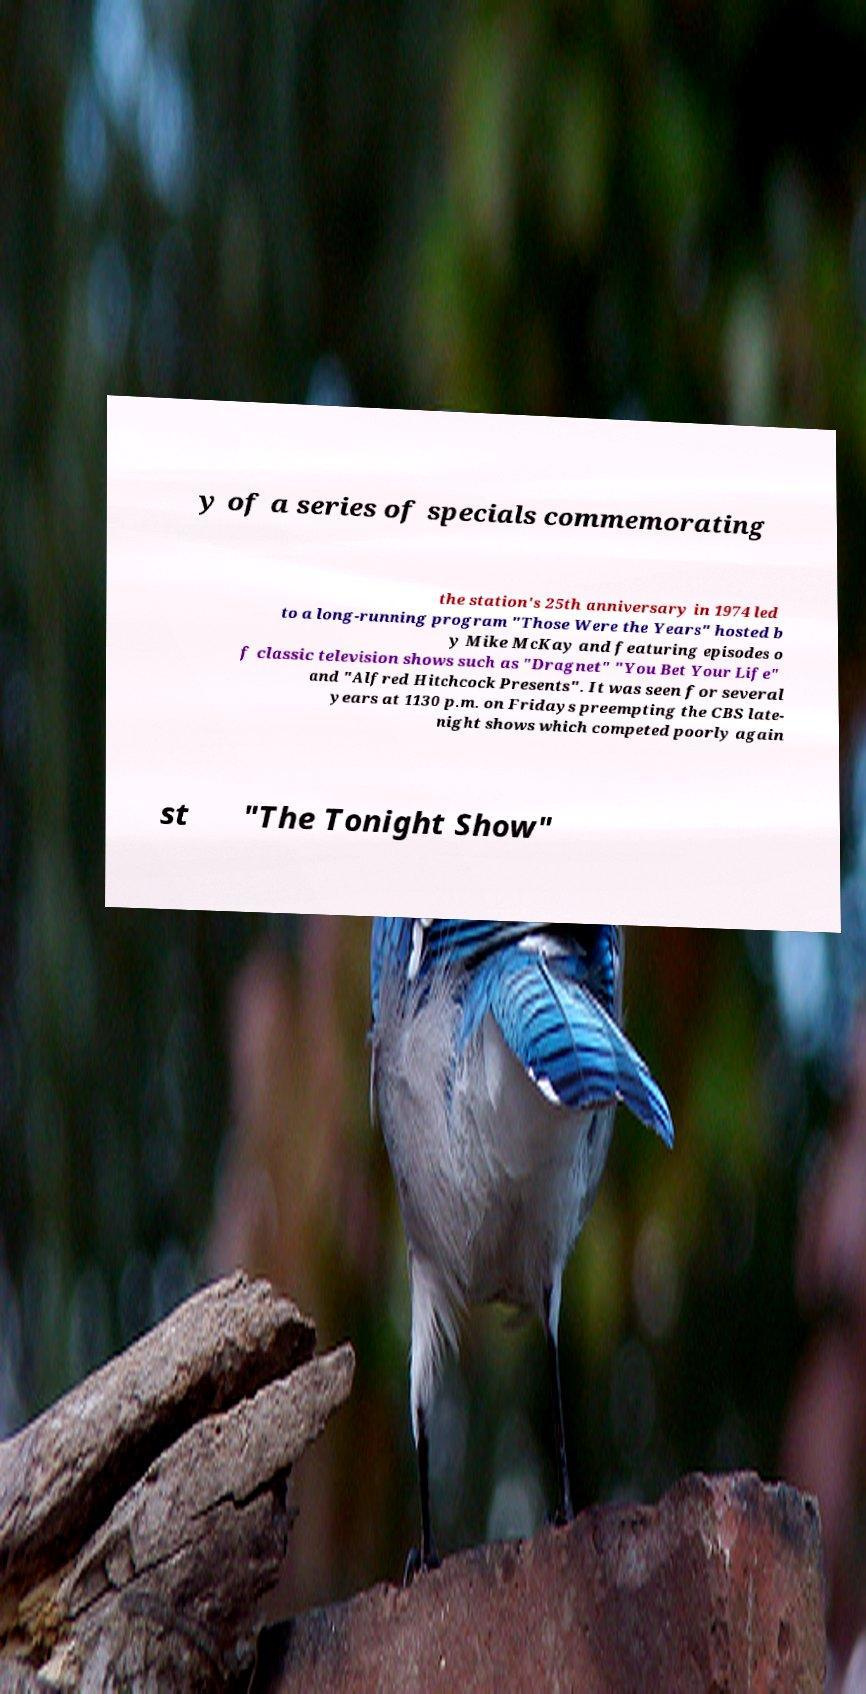What messages or text are displayed in this image? I need them in a readable, typed format. y of a series of specials commemorating the station's 25th anniversary in 1974 led to a long-running program "Those Were the Years" hosted b y Mike McKay and featuring episodes o f classic television shows such as "Dragnet" "You Bet Your Life" and "Alfred Hitchcock Presents". It was seen for several years at 1130 p.m. on Fridays preempting the CBS late- night shows which competed poorly again st "The Tonight Show" 